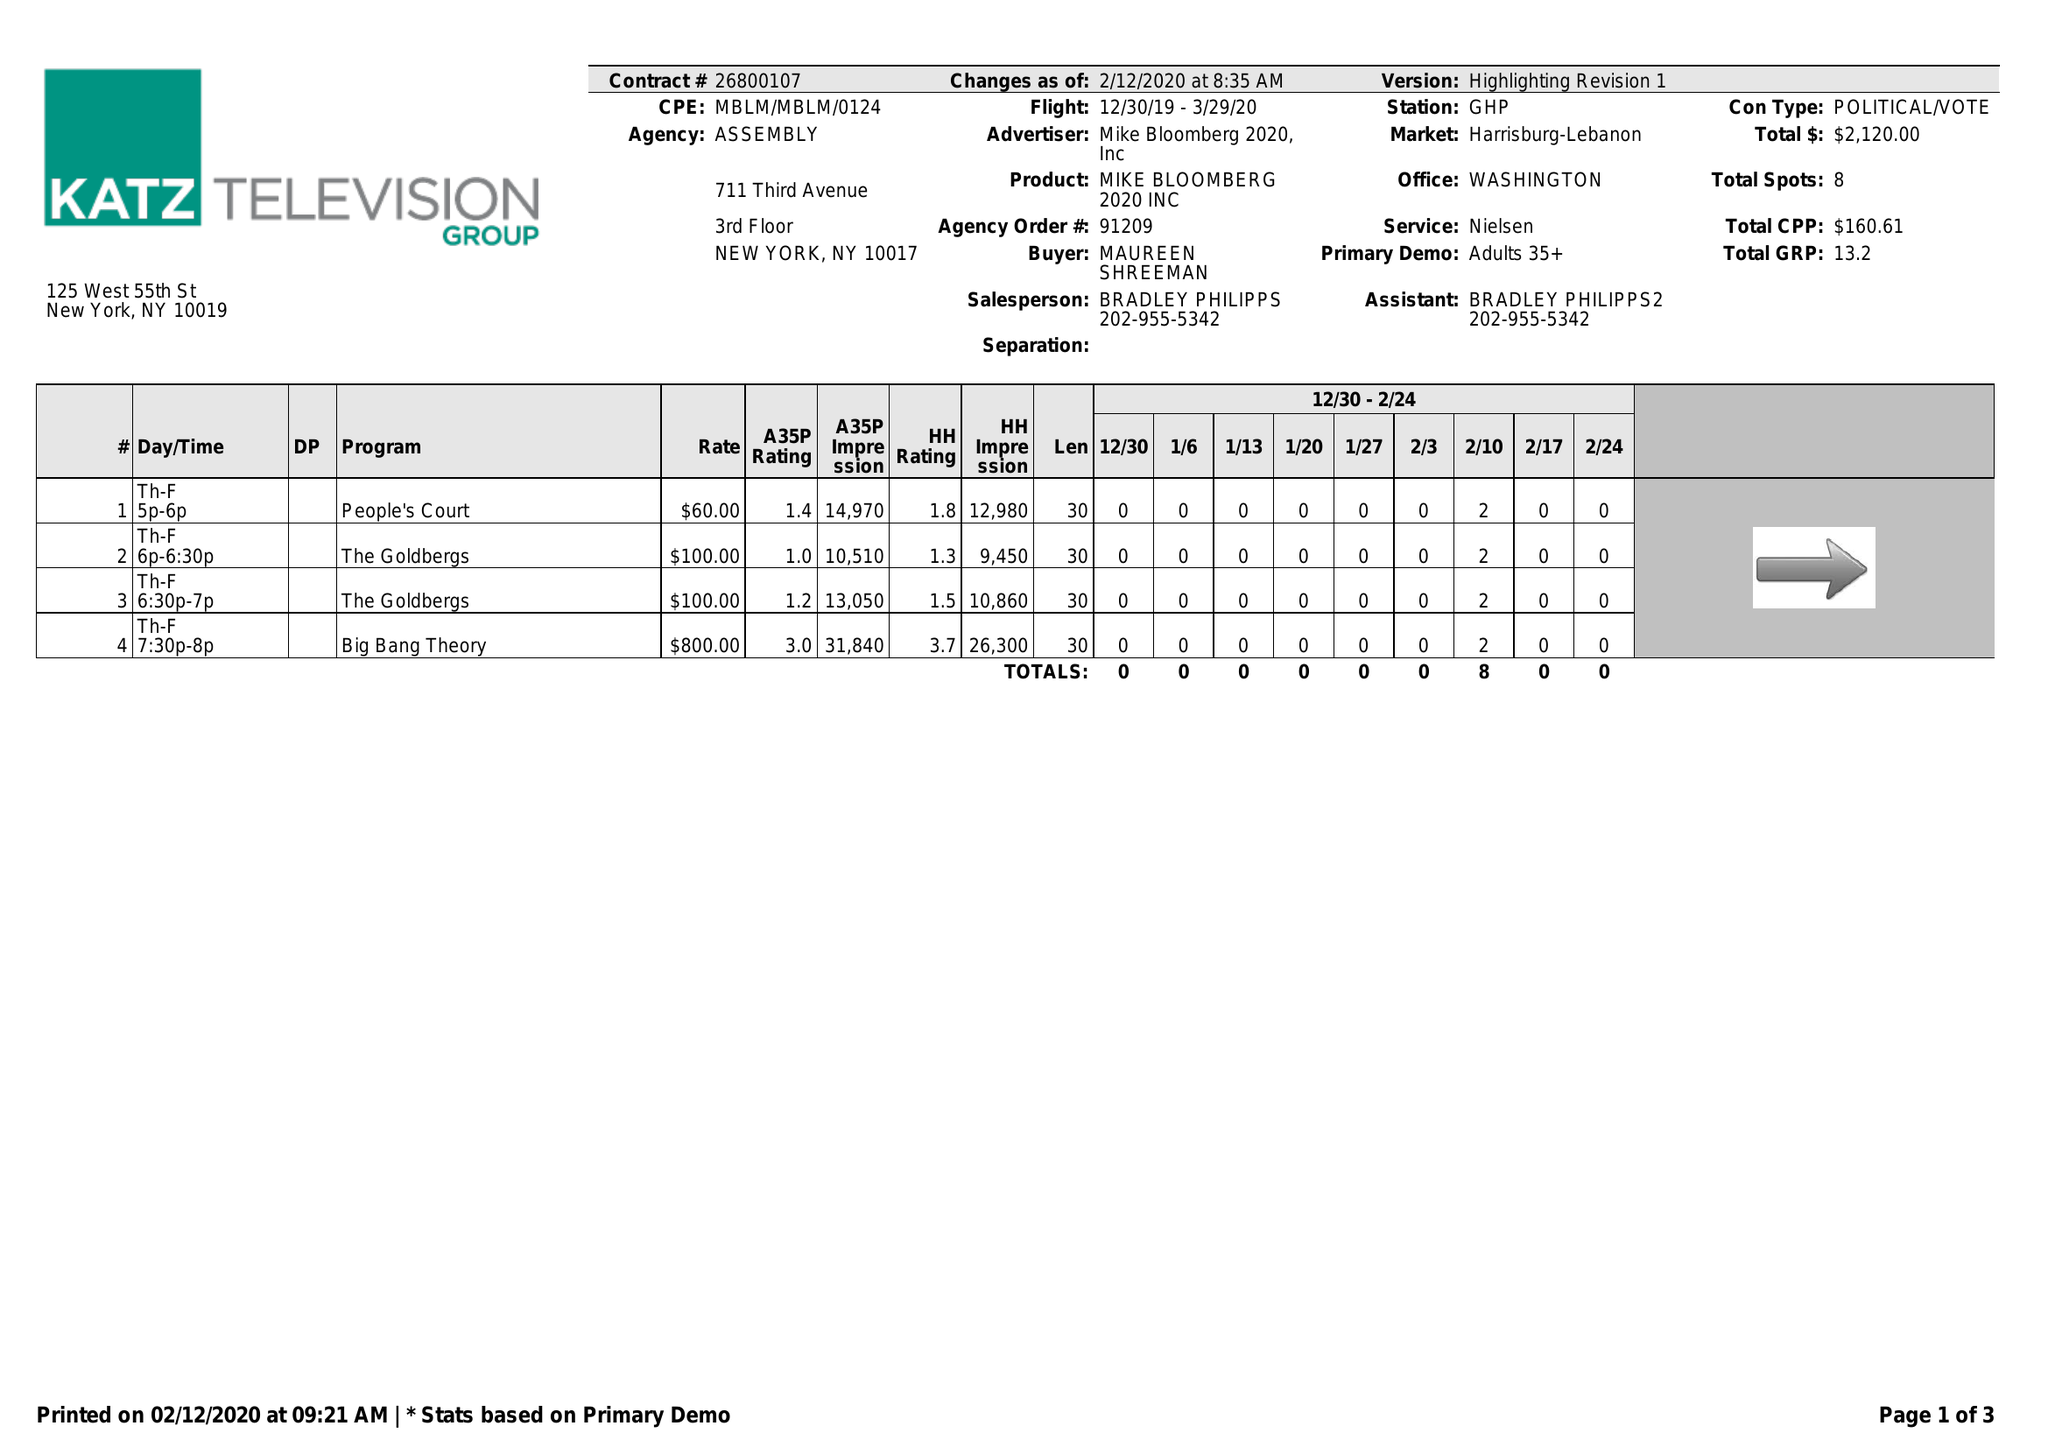What is the value for the advertiser?
Answer the question using a single word or phrase. MIKE BLOOMBERG 2020, INC 